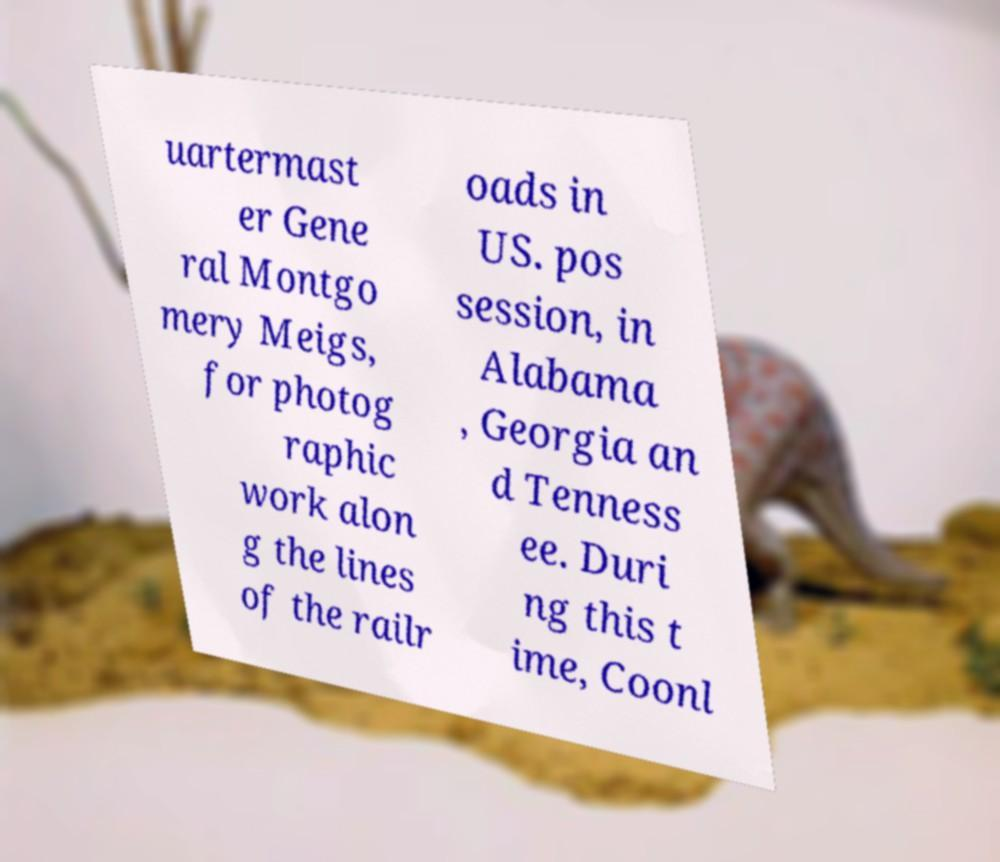Can you accurately transcribe the text from the provided image for me? uartermast er Gene ral Montgo mery Meigs, for photog raphic work alon g the lines of the railr oads in US. pos session, in Alabama , Georgia an d Tenness ee. Duri ng this t ime, Coonl 